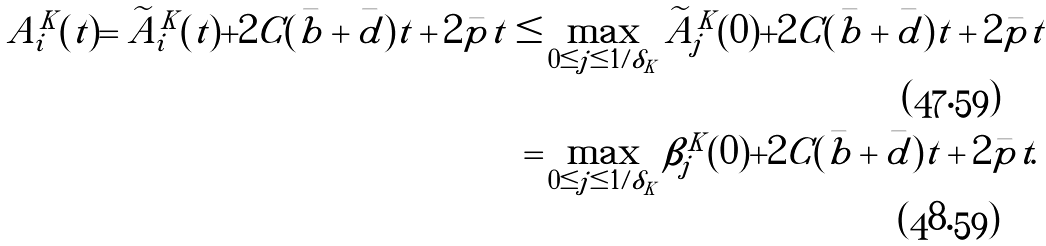Convert formula to latex. <formula><loc_0><loc_0><loc_500><loc_500>A ^ { K } _ { i } ( t ) = \widetilde { A } ^ { K } _ { i } ( t ) + 2 C ( \bar { b } + \bar { d } ) t + 2 \bar { p } t \leq & \max _ { 0 \leq j \leq 1 / \delta _ { K } } \widetilde { A } ^ { K } _ { j } ( 0 ) + 2 C ( \bar { b } + \bar { d } ) t + 2 \bar { p } t \\ = & \max _ { 0 \leq j \leq 1 / \delta _ { K } } \beta ^ { K } _ { j } ( 0 ) + 2 C ( \bar { b } + \bar { d } ) t + 2 \bar { p } t .</formula> 